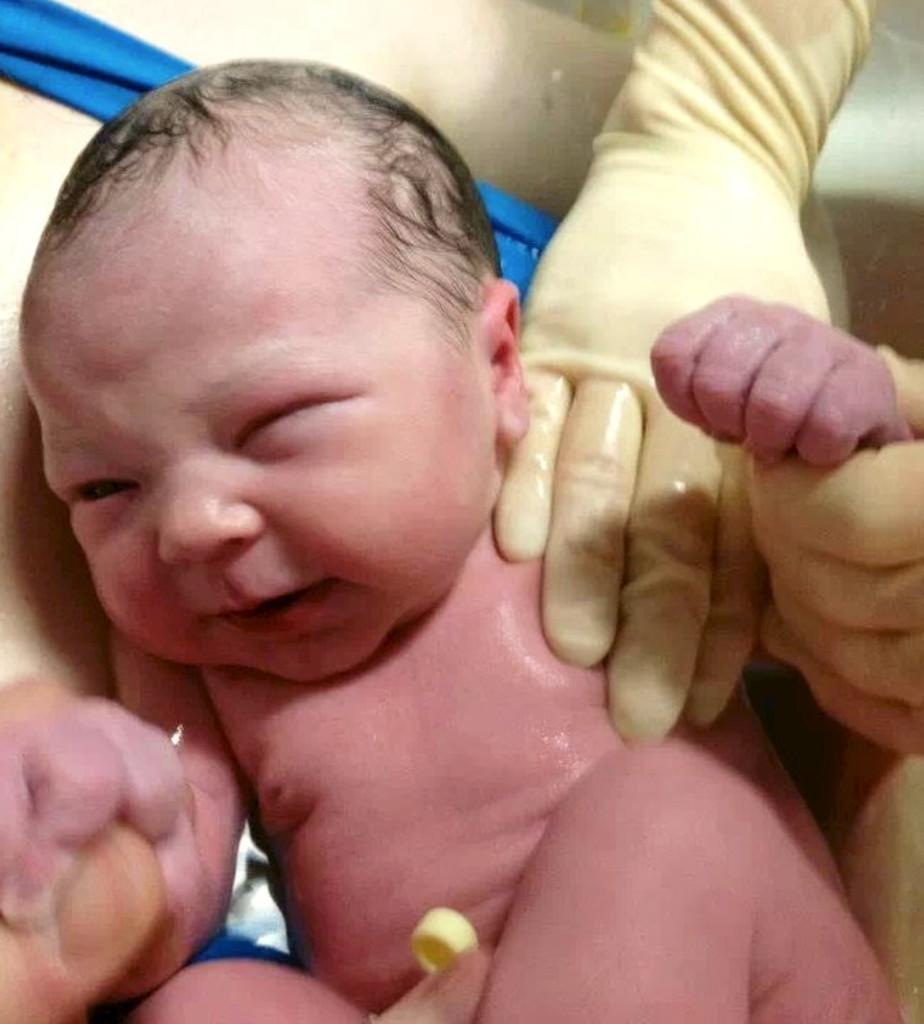How would you summarize this image in a sentence or two? In this image there is a newborn baby holding the finger of a person on the other hand, we can see the hands of the other person. 